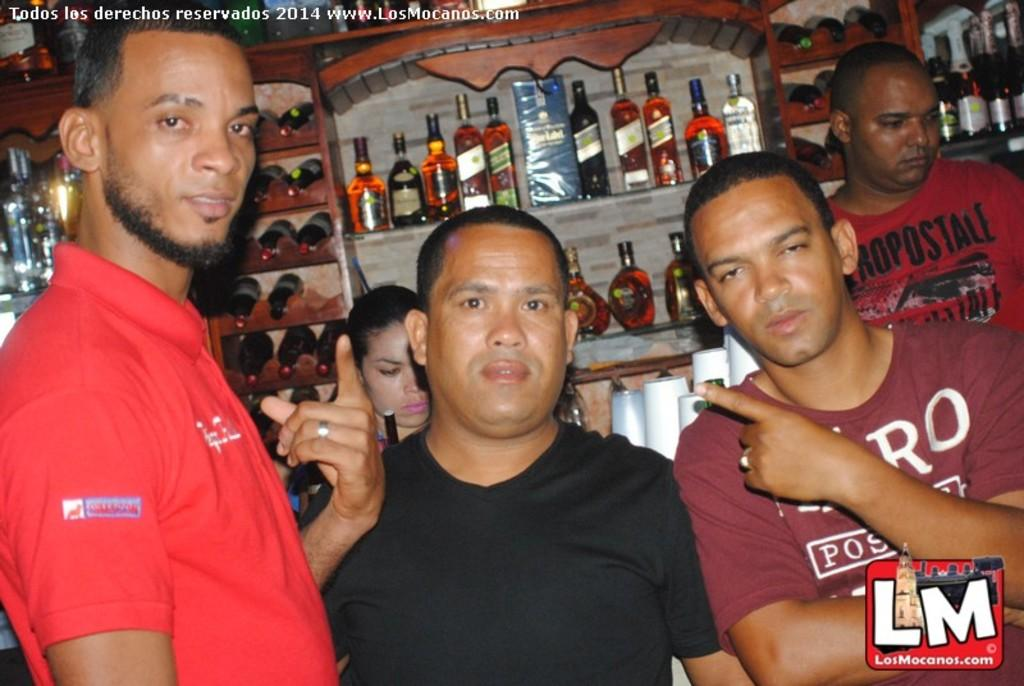Who or what can be seen in the image? There are people in the image. What is located in the background of the image? There is a rack filled with bottles in the background of the image. Can you describe any additional features of the image? There is a watermark at the top of the image. What is the title of the downtown scene in the image? There is no downtown scene present in the image, and therefore no title can be assigned to it. 